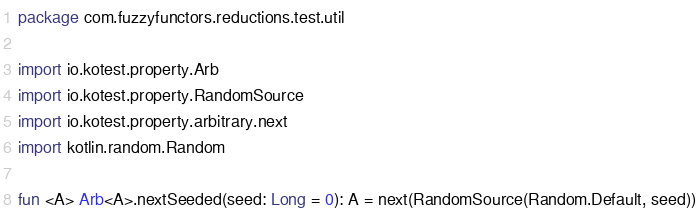<code> <loc_0><loc_0><loc_500><loc_500><_Kotlin_>package com.fuzzyfunctors.reductions.test.util

import io.kotest.property.Arb
import io.kotest.property.RandomSource
import io.kotest.property.arbitrary.next
import kotlin.random.Random

fun <A> Arb<A>.nextSeeded(seed: Long = 0): A = next(RandomSource(Random.Default, seed))
</code> 